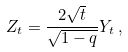<formula> <loc_0><loc_0><loc_500><loc_500>Z _ { t } = \frac { 2 \sqrt { t } } { \sqrt { 1 - q } } Y _ { t } \, ,</formula> 